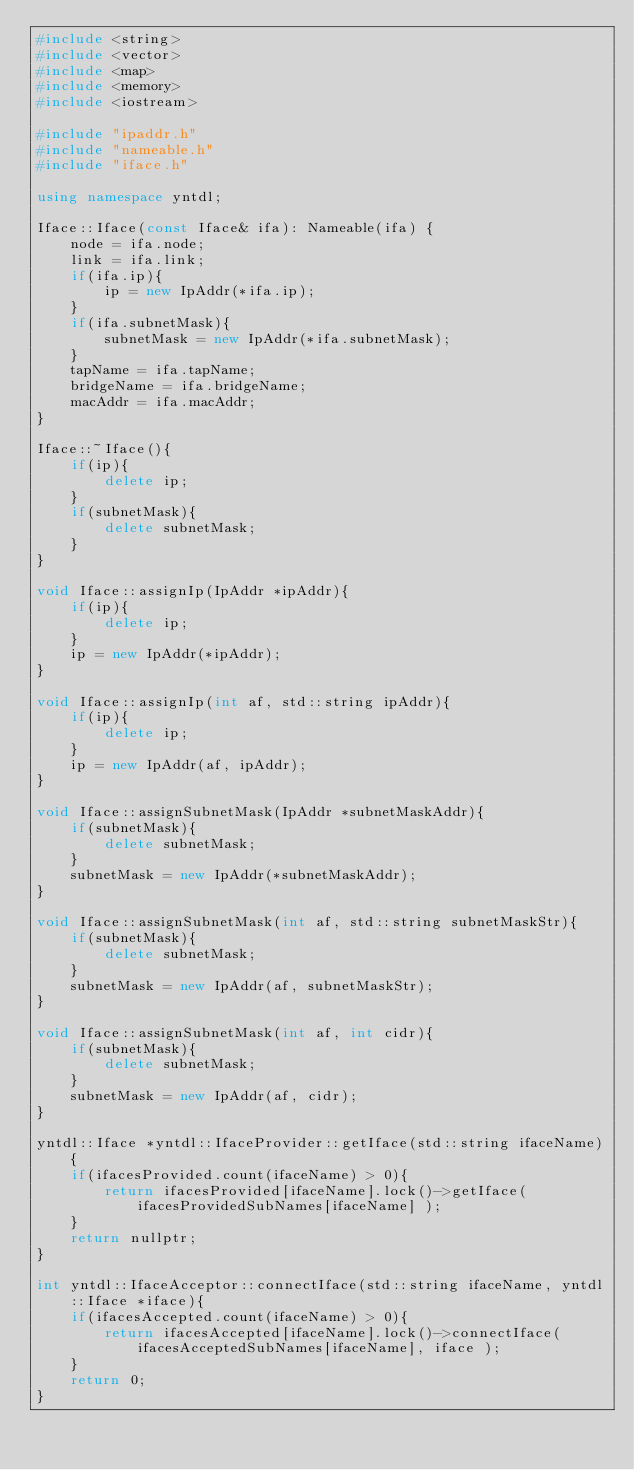Convert code to text. <code><loc_0><loc_0><loc_500><loc_500><_C++_>#include <string>
#include <vector>
#include <map>
#include <memory>
#include <iostream>

#include "ipaddr.h"
#include "nameable.h"
#include "iface.h"

using namespace yntdl;

Iface::Iface(const Iface& ifa): Nameable(ifa) {
    node = ifa.node;
    link = ifa.link;
    if(ifa.ip){
        ip = new IpAddr(*ifa.ip);
    }
    if(ifa.subnetMask){
        subnetMask = new IpAddr(*ifa.subnetMask);
    }
    tapName = ifa.tapName;
    bridgeName = ifa.bridgeName;
    macAddr = ifa.macAddr;
}

Iface::~Iface(){
    if(ip){
        delete ip;
    }
    if(subnetMask){
        delete subnetMask;
    }
}

void Iface::assignIp(IpAddr *ipAddr){
    if(ip){
        delete ip;
    }
    ip = new IpAddr(*ipAddr);
}

void Iface::assignIp(int af, std::string ipAddr){
    if(ip){
        delete ip;
    }
    ip = new IpAddr(af, ipAddr);
}

void Iface::assignSubnetMask(IpAddr *subnetMaskAddr){
    if(subnetMask){
        delete subnetMask;
    }
    subnetMask = new IpAddr(*subnetMaskAddr);
}

void Iface::assignSubnetMask(int af, std::string subnetMaskStr){
    if(subnetMask){
        delete subnetMask;
    }
    subnetMask = new IpAddr(af, subnetMaskStr);
}

void Iface::assignSubnetMask(int af, int cidr){
    if(subnetMask){
        delete subnetMask;
    }
    subnetMask = new IpAddr(af, cidr);
}

yntdl::Iface *yntdl::IfaceProvider::getIface(std::string ifaceName){
    if(ifacesProvided.count(ifaceName) > 0){
        return ifacesProvided[ifaceName].lock()->getIface( ifacesProvidedSubNames[ifaceName] );
    }
    return nullptr;
}

int yntdl::IfaceAcceptor::connectIface(std::string ifaceName, yntdl::Iface *iface){
    if(ifacesAccepted.count(ifaceName) > 0){
        return ifacesAccepted[ifaceName].lock()->connectIface( ifacesAcceptedSubNames[ifaceName], iface );
    }
    return 0;
}</code> 